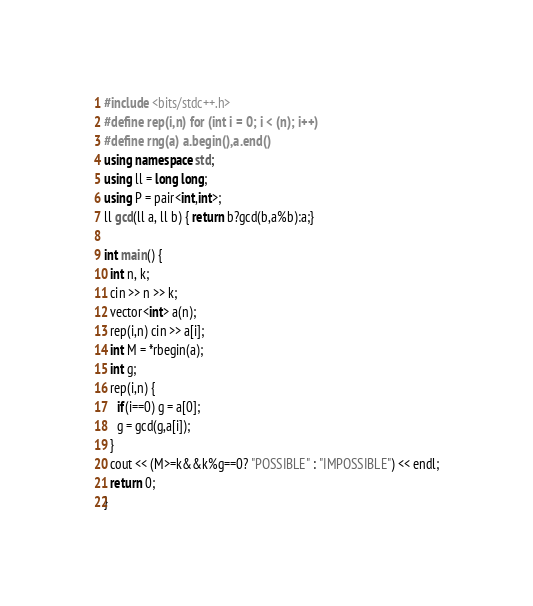<code> <loc_0><loc_0><loc_500><loc_500><_C++_>#include <bits/stdc++.h>
#define rep(i,n) for (int i = 0; i < (n); i++)
#define rng(a) a.begin(),a.end()
using namespace std;
using ll = long long;
using P = pair<int,int>;
ll gcd(ll a, ll b) { return b?gcd(b,a%b):a;}

int main() {
  int n, k;
  cin >> n >> k;
  vector<int> a(n);
  rep(i,n) cin >> a[i];
  int M = *rbegin(a);
  int g;
  rep(i,n) {
    if(i==0) g = a[0];
    g = gcd(g,a[i]);
  }
  cout << (M>=k&&k%g==0? "POSSIBLE" : "IMPOSSIBLE") << endl;
  return 0;
}</code> 